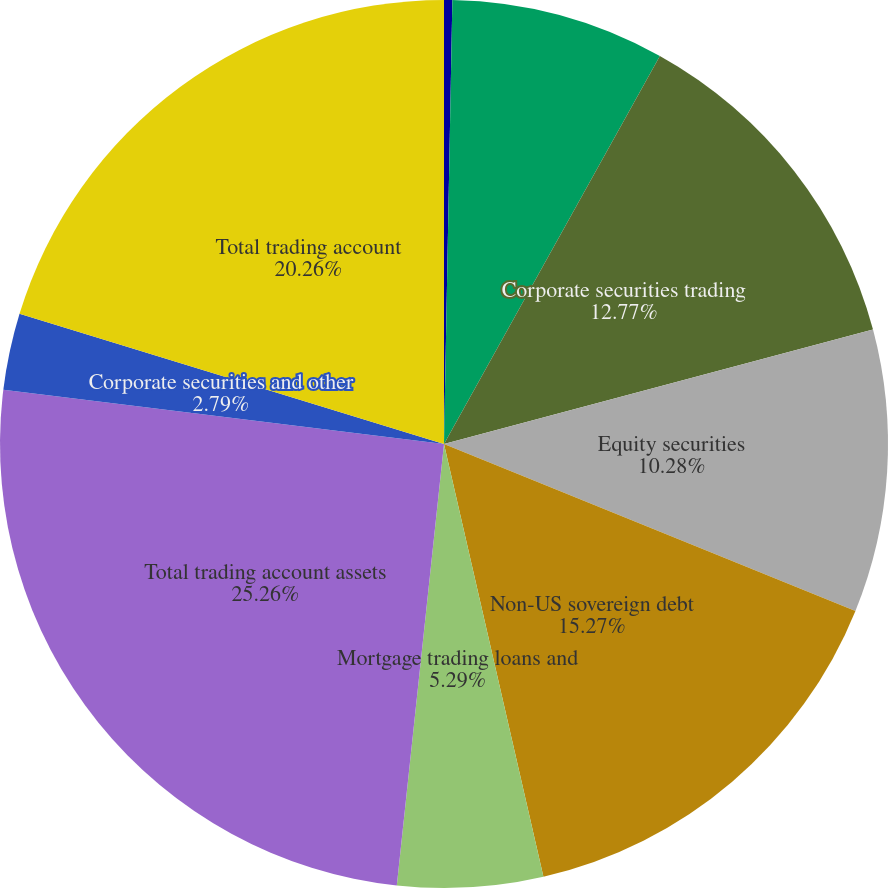Convert chart to OTSL. <chart><loc_0><loc_0><loc_500><loc_500><pie_chart><fcel>(Dollars in millions)<fcel>US government and agency<fcel>Corporate securities trading<fcel>Equity securities<fcel>Non-US sovereign debt<fcel>Mortgage trading loans and<fcel>Total trading account assets<fcel>Corporate securities and other<fcel>Total trading account<nl><fcel>0.3%<fcel>7.78%<fcel>12.77%<fcel>10.28%<fcel>15.27%<fcel>5.29%<fcel>25.25%<fcel>2.79%<fcel>20.26%<nl></chart> 